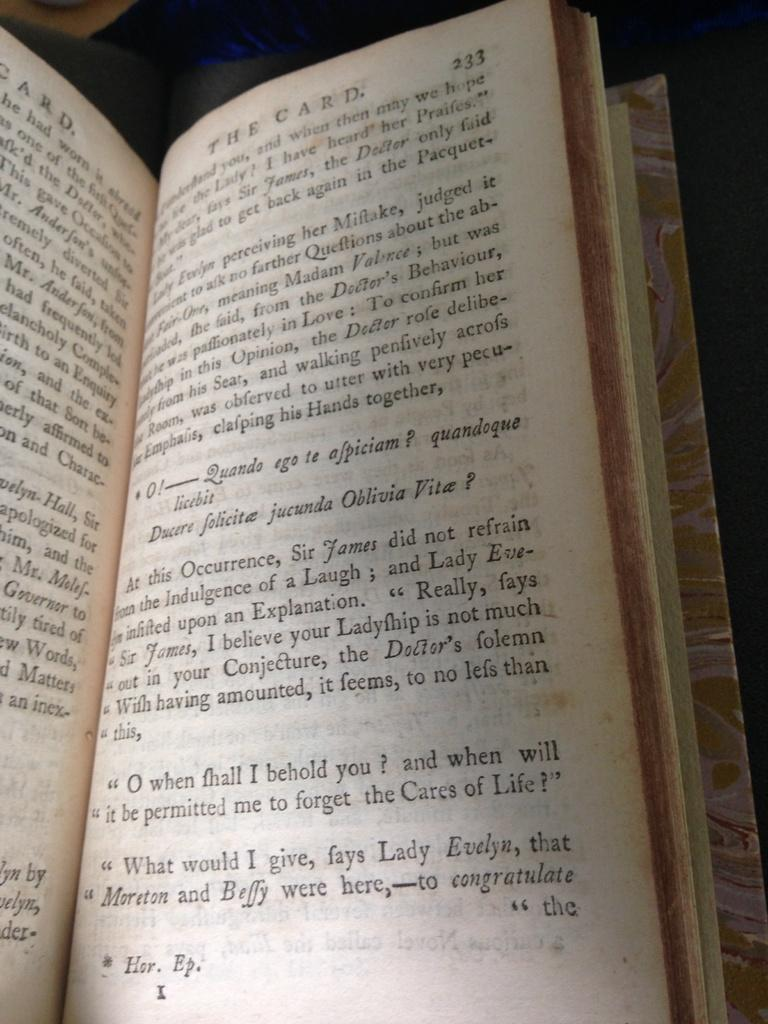<image>
Summarize the visual content of the image. Page 233 of The Card and it's contents consist of several paragraphs. 